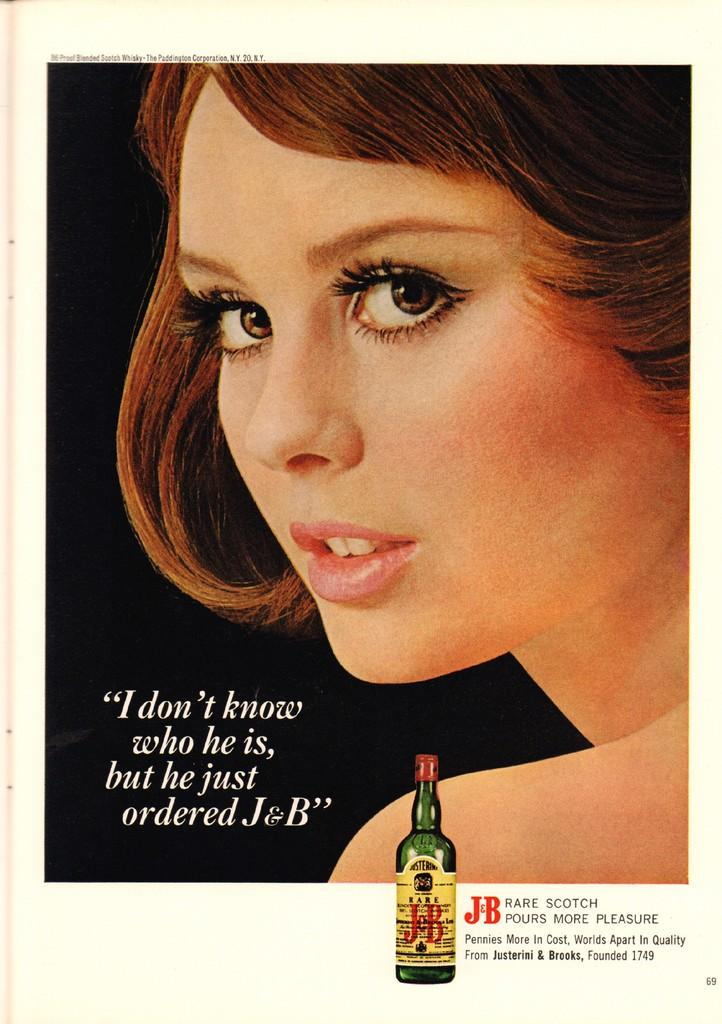Who is present in the image? There is a woman in the image. What else can be seen in the image besides the woman? There is text visible in the image and a glass bottle at the bottom of the image. What type of stone is the goat standing on in the image? There is no goat present in the image, so it is not possible to determine what type of stone it might be standing on. 